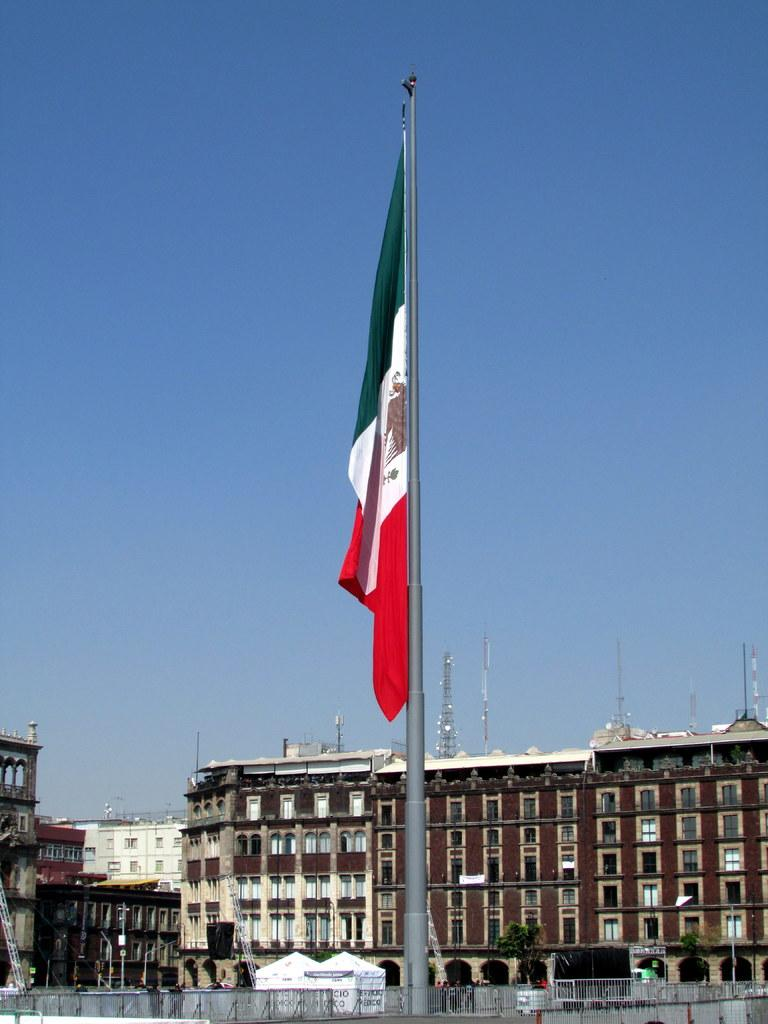What can be seen in the sky in the image? The sky is visible in the image. What structures are present in the image? There are towers, a flag post, and buildings in the image. What is attached to the flag post? There is a flag attached to the flag post in the image. What type of vegetation is present in the image? Trees are present in the image. What type of architectural feature can be seen in the image? Iron grills are visible in the image. Can you tell me how many worms are crawling on the flag in the image? There are no worms present in the image, as it features a flag on a flag post, towers, buildings, trees, and iron grills. 